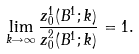<formula> <loc_0><loc_0><loc_500><loc_500>\lim _ { k \rightarrow \infty } \frac { z _ { 0 } ^ { 1 } ( B ^ { 1 } ; k ) } { z _ { 0 } ^ { 2 } ( B ^ { 1 } ; k ) } = 1 .</formula> 